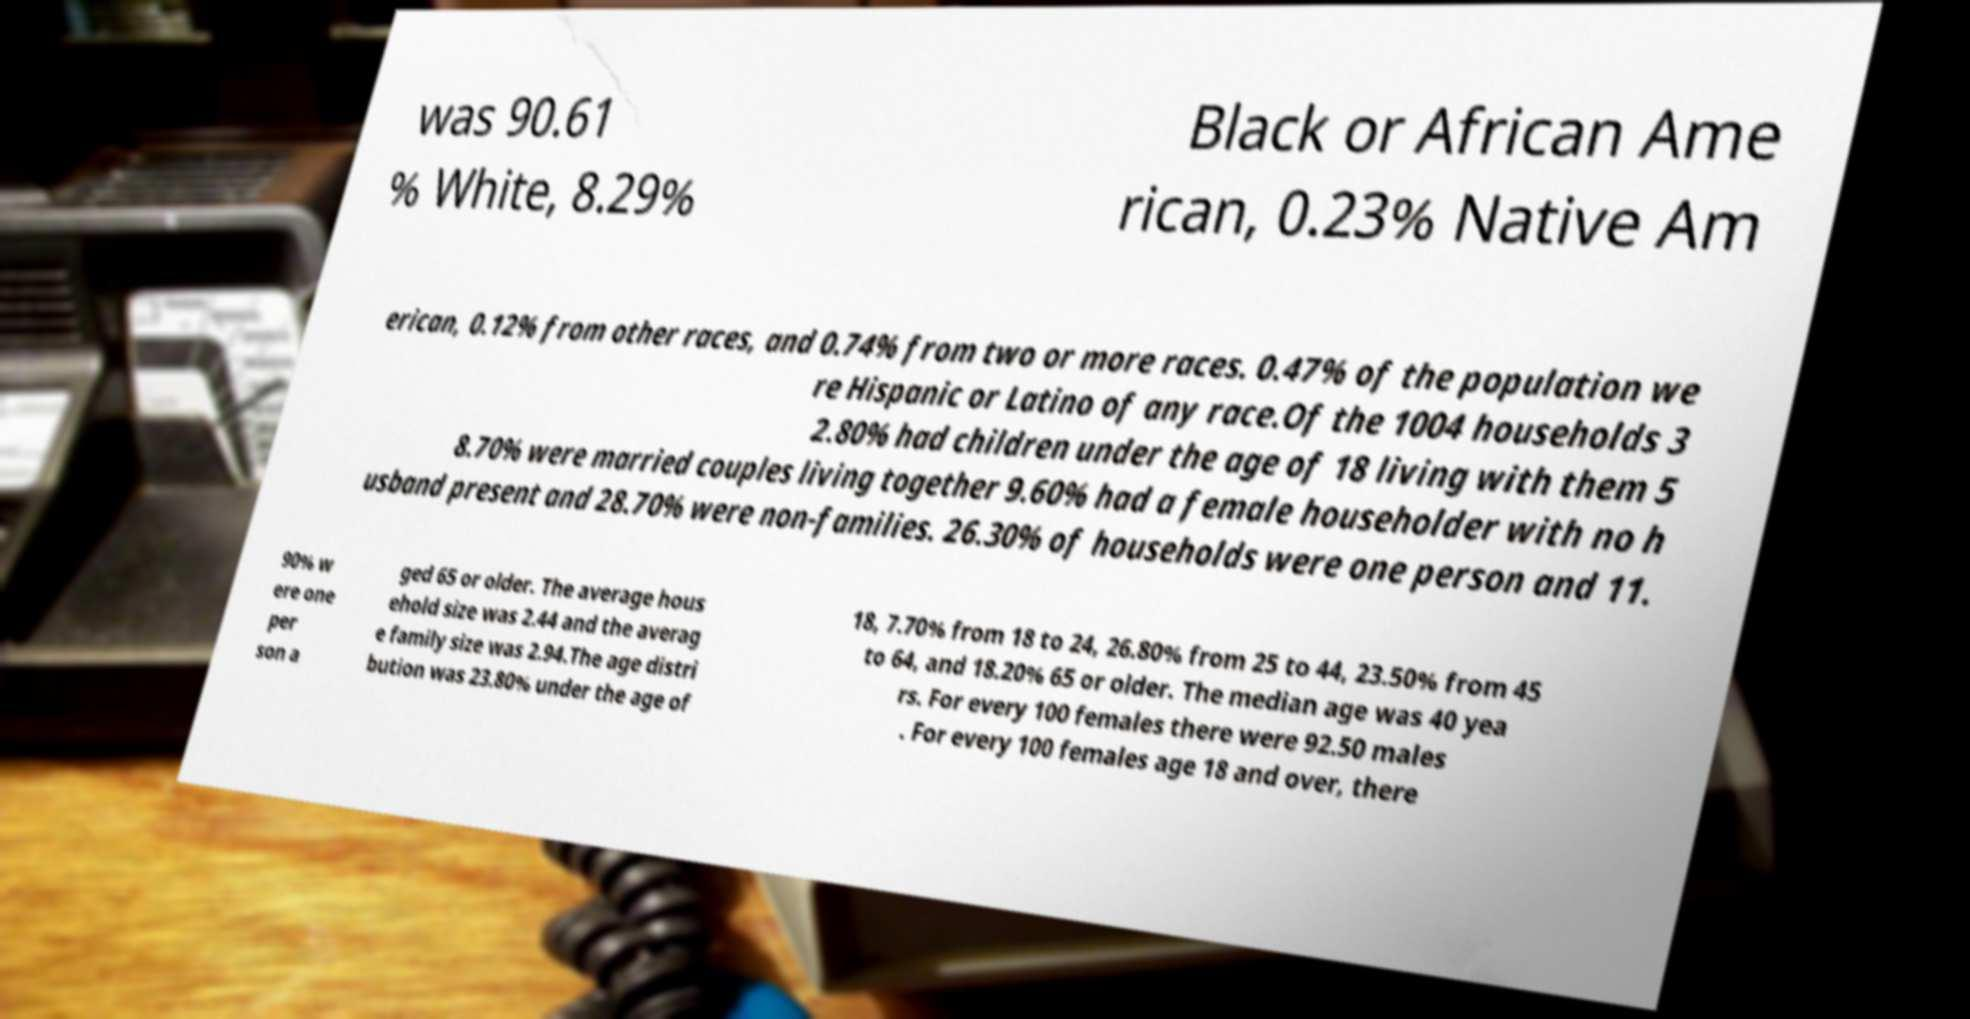Can you read and provide the text displayed in the image?This photo seems to have some interesting text. Can you extract and type it out for me? was 90.61 % White, 8.29% Black or African Ame rican, 0.23% Native Am erican, 0.12% from other races, and 0.74% from two or more races. 0.47% of the population we re Hispanic or Latino of any race.Of the 1004 households 3 2.80% had children under the age of 18 living with them 5 8.70% were married couples living together 9.60% had a female householder with no h usband present and 28.70% were non-families. 26.30% of households were one person and 11. 90% w ere one per son a ged 65 or older. The average hous ehold size was 2.44 and the averag e family size was 2.94.The age distri bution was 23.80% under the age of 18, 7.70% from 18 to 24, 26.80% from 25 to 44, 23.50% from 45 to 64, and 18.20% 65 or older. The median age was 40 yea rs. For every 100 females there were 92.50 males . For every 100 females age 18 and over, there 